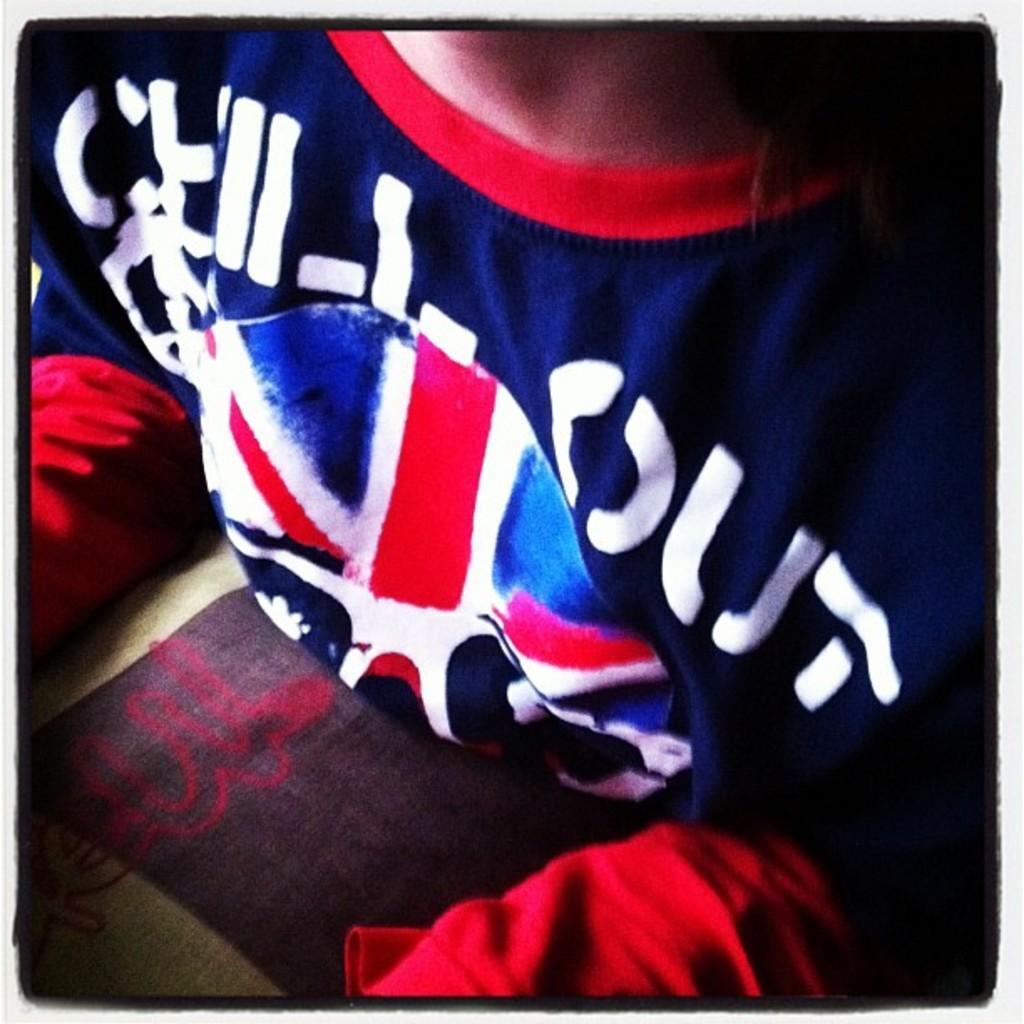<image>
Describe the image concisely. A person is wearing a red, white, and blue shirt that reads "chill out" 